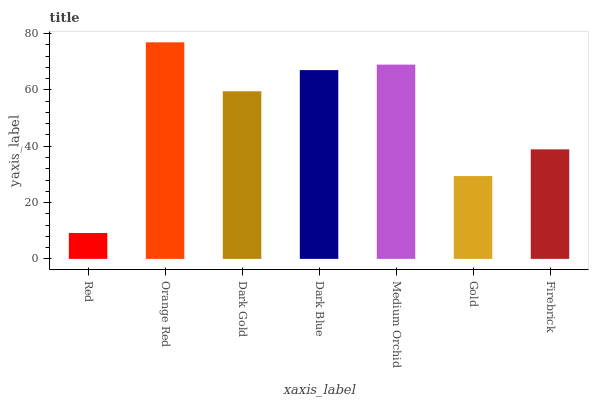Is Red the minimum?
Answer yes or no. Yes. Is Orange Red the maximum?
Answer yes or no. Yes. Is Dark Gold the minimum?
Answer yes or no. No. Is Dark Gold the maximum?
Answer yes or no. No. Is Orange Red greater than Dark Gold?
Answer yes or no. Yes. Is Dark Gold less than Orange Red?
Answer yes or no. Yes. Is Dark Gold greater than Orange Red?
Answer yes or no. No. Is Orange Red less than Dark Gold?
Answer yes or no. No. Is Dark Gold the high median?
Answer yes or no. Yes. Is Dark Gold the low median?
Answer yes or no. Yes. Is Red the high median?
Answer yes or no. No. Is Gold the low median?
Answer yes or no. No. 